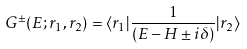Convert formula to latex. <formula><loc_0><loc_0><loc_500><loc_500>G ^ { \pm } ( E ; { r } _ { 1 } , { r } _ { 2 } ) = \langle { r } _ { 1 } | \frac { 1 } { ( E - H \pm i \delta ) } | { r } _ { 2 } \rangle</formula> 